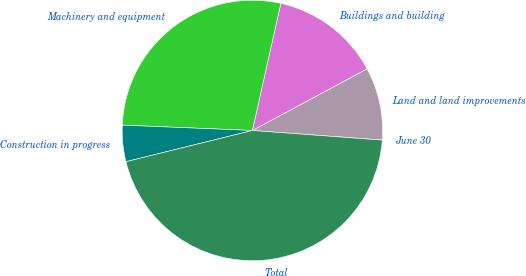<chart> <loc_0><loc_0><loc_500><loc_500><pie_chart><fcel>June 30<fcel>Land and land improvements<fcel>Buildings and building<fcel>Machinery and equipment<fcel>Construction in progress<fcel>Total<nl><fcel>0.02%<fcel>9.01%<fcel>13.65%<fcel>27.85%<fcel>4.51%<fcel>44.97%<nl></chart> 